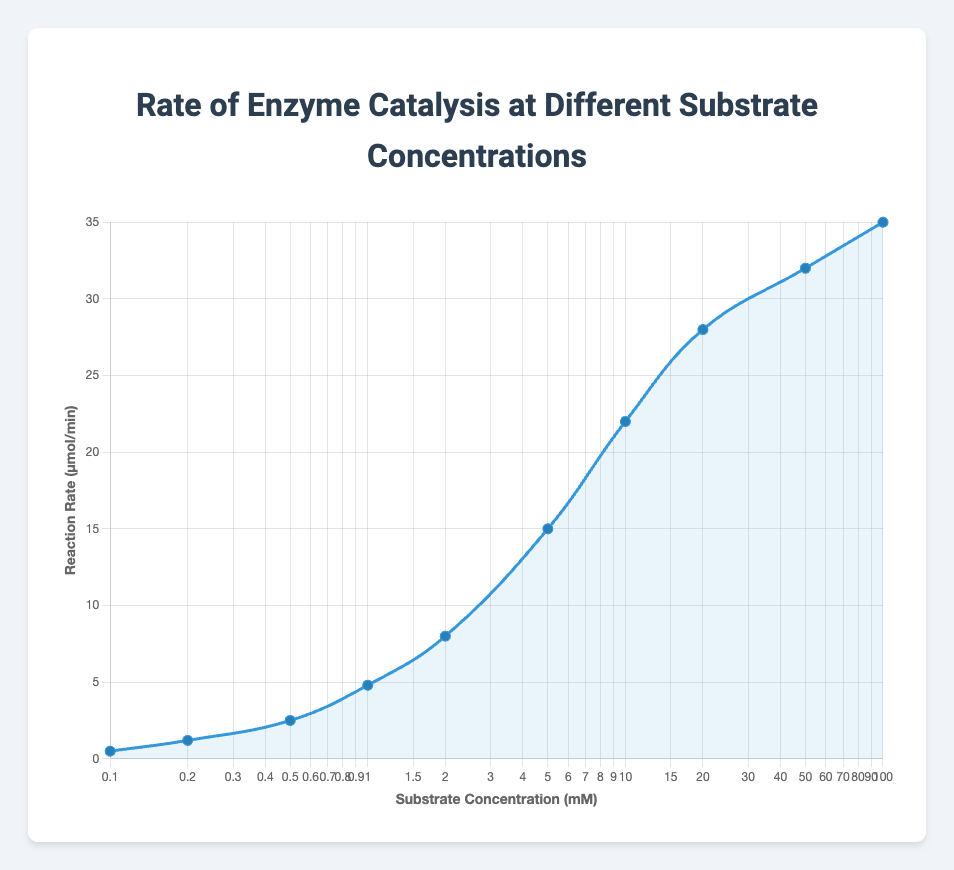What is the reaction rate at a substrate concentration of 5.0 mM? The reaction rate at a substrate concentration of 5.0 mM can be directly observed from the y-axis corresponding to the x-axis value of 5.0 mM.
Answer: 15.0 μmol/min Does the reaction rate increase or decrease as the substrate concentration increases from 0.1 mM to 2.0 mM? By examining the plot, the reaction rate increases as the substrate concentration increases from 0.1 mM to 2.0 mM.
Answer: Increases Which substrate concentration has the highest reaction rate? By looking at the highest point on the y-axis, we can see that the substrate concentration with the highest reaction rate is 100.0 mM.
Answer: 100.0 mM How much does the reaction rate change when the substrate concentration increases from 10.0 mM to 100.0 mM? The reaction rate at 10.0 mM is 22.0 μmol/min and at 100.0 mM, it is 35.0 μmol/min. The change is calculated as 35.0 - 22.0 = 13.0 μmol/min.
Answer: 13.0 μmol/min At which substrate concentration does the reaction rate first exceed 10.0 μmol/min? Observing the plot, the reaction rate first exceeds 10.0 μmol/min at a substrate concentration of 5.0 mM.
Answer: 5.0 mM Compare the reaction rates at substrate concentrations of 2.0 mM and 20.0 mM. Which is higher and by how much? The reaction rate at 2.0 mM is 8.0 μmol/min and at 20.0 mM, it is 28.0 μmol/min. The difference is 28.0 - 8.0 = 20.0 μmol/min, so the rate at 20.0 mM is higher by 20.0 μmol/min.
Answer: 20.0 mM by 20.0 μmol/min What is the average reaction rate for substrate concentrations of 0.1 mM, 1.0 mM, and 5.0 mM? First, find the reaction rates: 0.5, 4.8, and 15.0 μmol/min. Sum them up: 0.5 + 4.8 + 15.0 = 20.3 μmol/min. Then, divide by the number of data points: 20.3 / 3 = 6.77 μmol/min.
Answer: 6.77 μmol/min Describe the trend of the reaction rate as substrate concentration increases. The reaction rate increases rapidly at lower substrate concentrations, but the rate of increase slows down and eventually plateaus at higher concentrations.
Answer: Increases rapidly then plateaus 